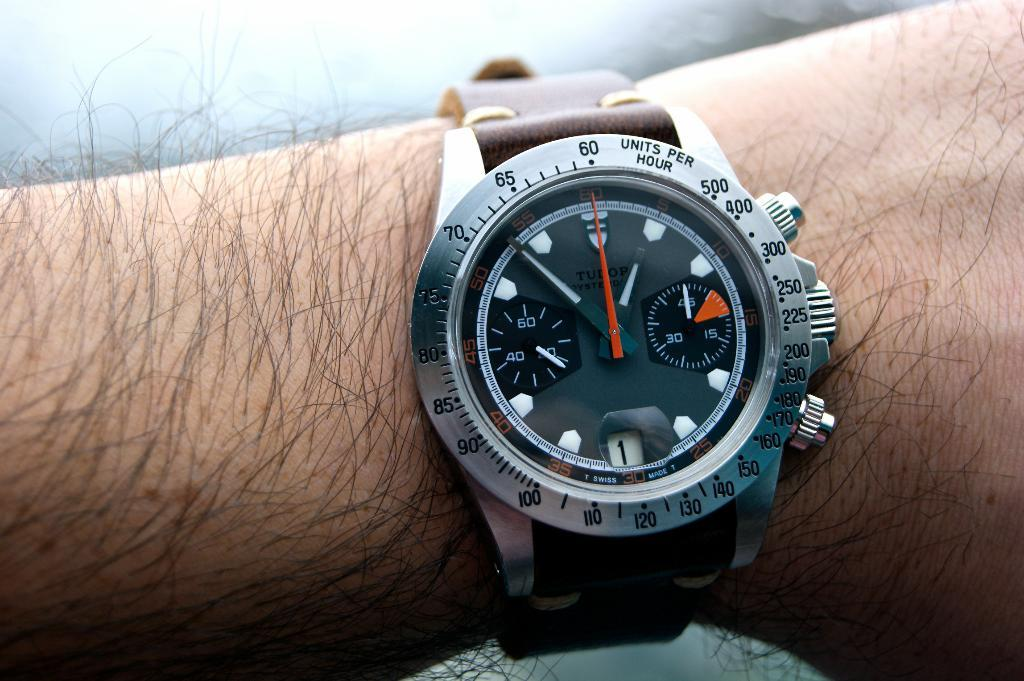<image>
Render a clear and concise summary of the photo. a man wearing a watch with the words Swiss Made at the bottom. 